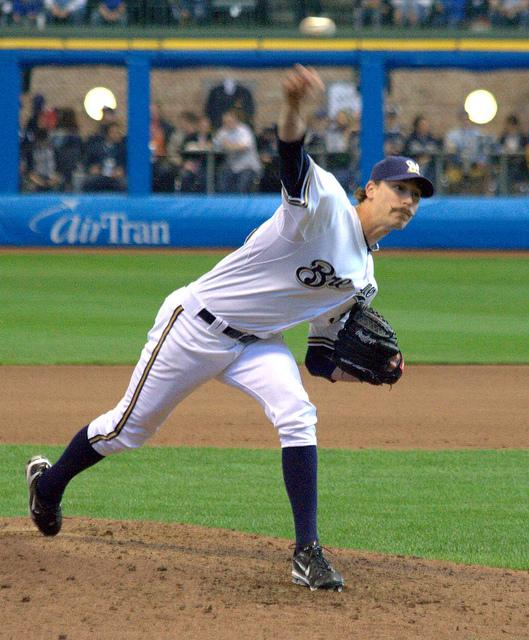To whom is this ball thrown? Please explain your reasoning. batter. The ball is going to the batter. 